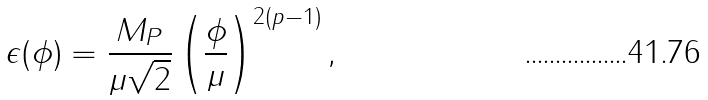Convert formula to latex. <formula><loc_0><loc_0><loc_500><loc_500>\epsilon ( \phi ) = \frac { M _ { P } } { \mu \sqrt { 2 } } \left ( \frac { \phi } { \mu } \right ) ^ { 2 ( p - 1 ) } ,</formula> 